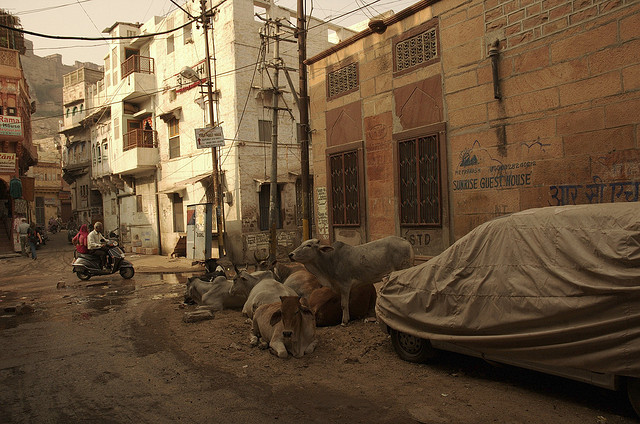<image>What event happened here? It is unclear what event happened here. The answers range from war, parade, poverty, market, killing, to flood. What event happened here? It is ambiguous what event happened here. It could be war, parade, poverty, market, killing, flood, or despair. 